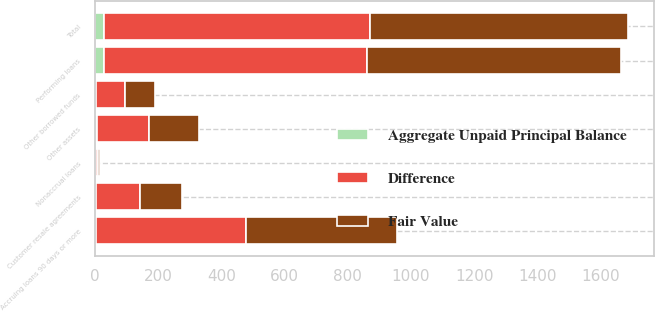Convert chart to OTSL. <chart><loc_0><loc_0><loc_500><loc_500><stacked_bar_chart><ecel><fcel>Customer resale agreements<fcel>Performing loans<fcel>Nonaccrual loans<fcel>Total<fcel>Accruing loans 90 days or more<fcel>Other assets<fcel>Other borrowed funds<nl><fcel>Difference<fcel>137<fcel>832<fcel>7<fcel>843<fcel>475<fcel>164<fcel>93<nl><fcel>Fair Value<fcel>133<fcel>804<fcel>8<fcel>816<fcel>478<fcel>159<fcel>95<nl><fcel>Aggregate Unpaid Principal Balance<fcel>4<fcel>28<fcel>1<fcel>27<fcel>3<fcel>5<fcel>2<nl></chart> 